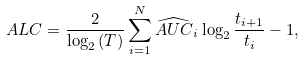<formula> <loc_0><loc_0><loc_500><loc_500>A L C = \frac { 2 } { \log _ { 2 } { ( T ) } } \sum _ { i = 1 } ^ { N } \widehat { A U C } _ { i } \log _ { 2 } { \frac { t _ { i + 1 } } { t _ { i } } } - 1 ,</formula> 